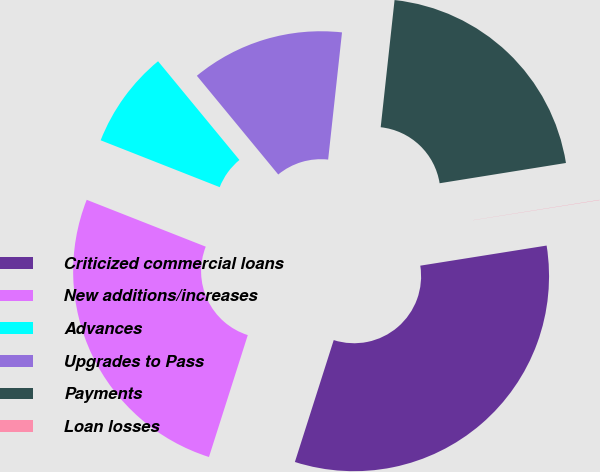Convert chart. <chart><loc_0><loc_0><loc_500><loc_500><pie_chart><fcel>Criticized commercial loans<fcel>New additions/increases<fcel>Advances<fcel>Upgrades to Pass<fcel>Payments<fcel>Loan losses<nl><fcel>32.42%<fcel>26.06%<fcel>8.06%<fcel>12.7%<fcel>20.74%<fcel>0.02%<nl></chart> 